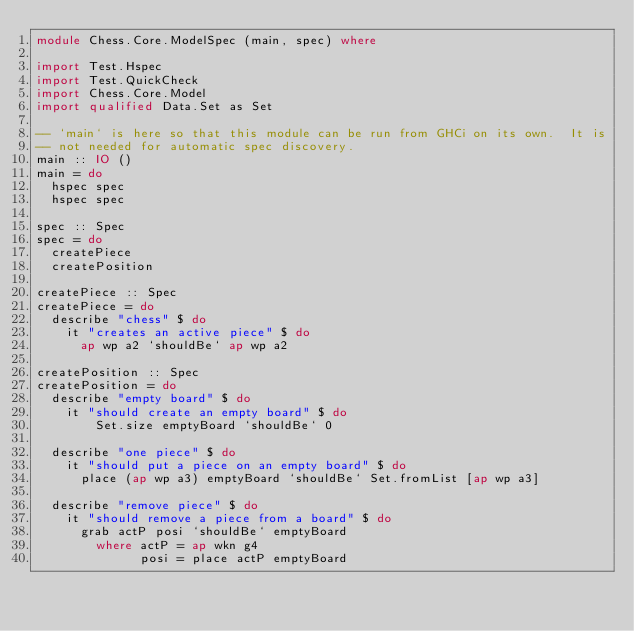<code> <loc_0><loc_0><loc_500><loc_500><_Haskell_>module Chess.Core.ModelSpec (main, spec) where

import Test.Hspec
import Test.QuickCheck
import Chess.Core.Model
import qualified Data.Set as Set

-- `main` is here so that this module can be run from GHCi on its own.  It is
-- not needed for automatic spec discovery.
main :: IO ()
main = do
  hspec spec
  hspec spec

spec :: Spec
spec = do
  createPiece
  createPosition

createPiece :: Spec
createPiece = do
  describe "chess" $ do
    it "creates an active piece" $ do
      ap wp a2 `shouldBe` ap wp a2

createPosition :: Spec
createPosition = do
  describe "empty board" $ do
    it "should create an empty board" $ do
        Set.size emptyBoard `shouldBe` 0

  describe "one piece" $ do
    it "should put a piece on an empty board" $ do
      place (ap wp a3) emptyBoard `shouldBe` Set.fromList [ap wp a3]

  describe "remove piece" $ do
    it "should remove a piece from a board" $ do
      grab actP posi `shouldBe` emptyBoard
        where actP = ap wkn g4
              posi = place actP emptyBoard</code> 